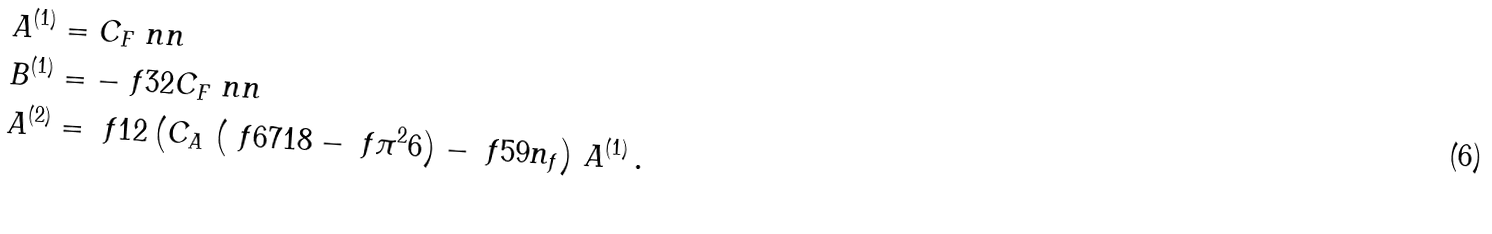Convert formula to latex. <formula><loc_0><loc_0><loc_500><loc_500>A ^ { ( 1 ) } & = C _ { F } \ n n \\ B ^ { ( 1 ) } & = - \ f { 3 } { 2 } C _ { F } \ n n \\ A ^ { ( 2 ) } & = \ f { 1 } { 2 } \left ( C _ { A } \, \left ( \ f { 6 7 } { 1 8 } - \ f { { \pi } ^ { 2 } } { 6 } \right ) - \ f { 5 } { 9 } n _ { f } \right ) \, A ^ { ( 1 ) } \, .</formula> 